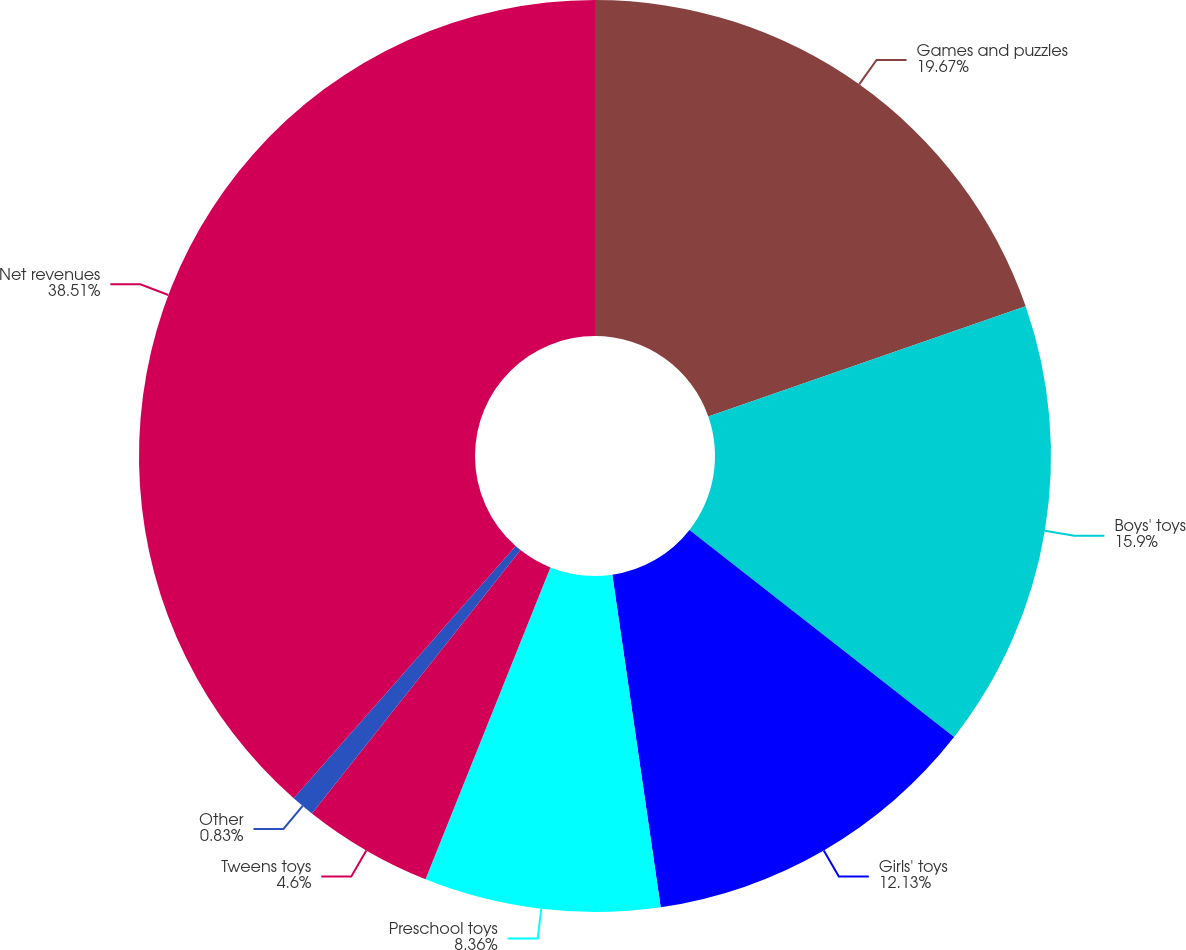Convert chart. <chart><loc_0><loc_0><loc_500><loc_500><pie_chart><fcel>Games and puzzles<fcel>Boys' toys<fcel>Girls' toys<fcel>Preschool toys<fcel>Tweens toys<fcel>Other<fcel>Net revenues<nl><fcel>19.67%<fcel>15.9%<fcel>12.13%<fcel>8.36%<fcel>4.6%<fcel>0.83%<fcel>38.51%<nl></chart> 